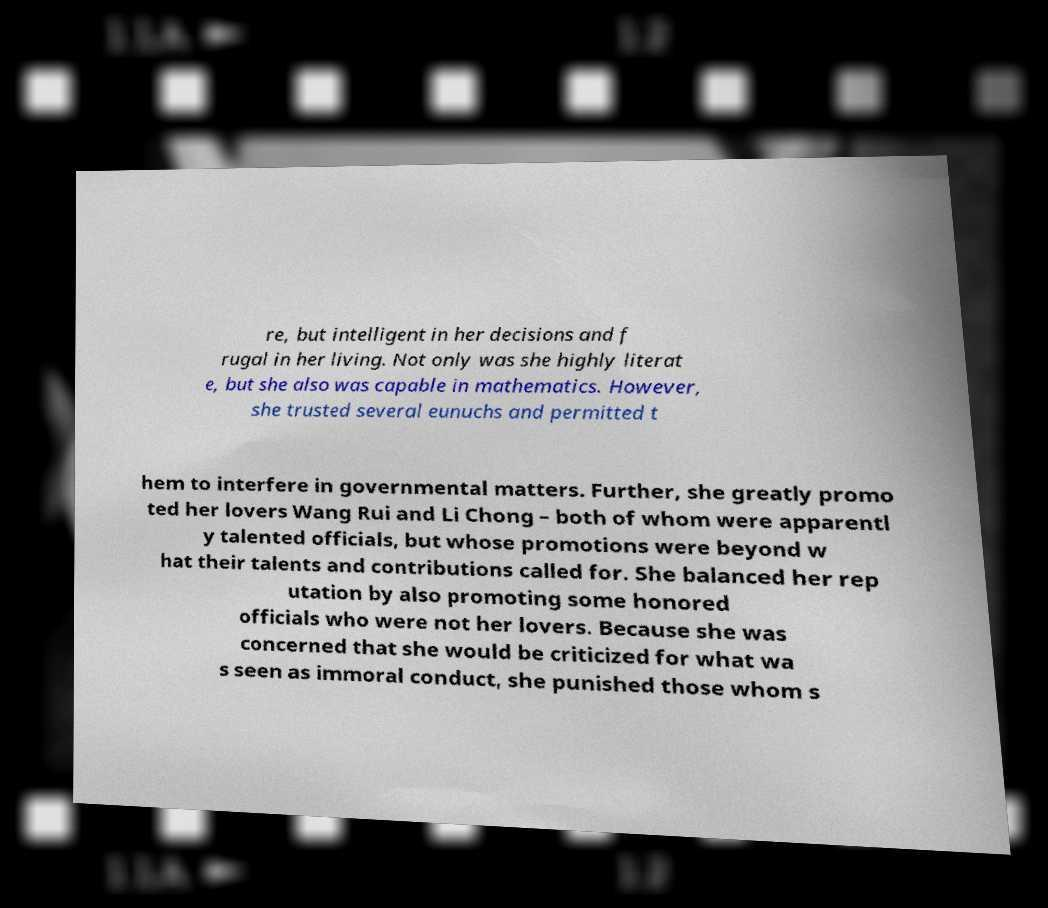Could you extract and type out the text from this image? re, but intelligent in her decisions and f rugal in her living. Not only was she highly literat e, but she also was capable in mathematics. However, she trusted several eunuchs and permitted t hem to interfere in governmental matters. Further, she greatly promo ted her lovers Wang Rui and Li Chong – both of whom were apparentl y talented officials, but whose promotions were beyond w hat their talents and contributions called for. She balanced her rep utation by also promoting some honored officials who were not her lovers. Because she was concerned that she would be criticized for what wa s seen as immoral conduct, she punished those whom s 